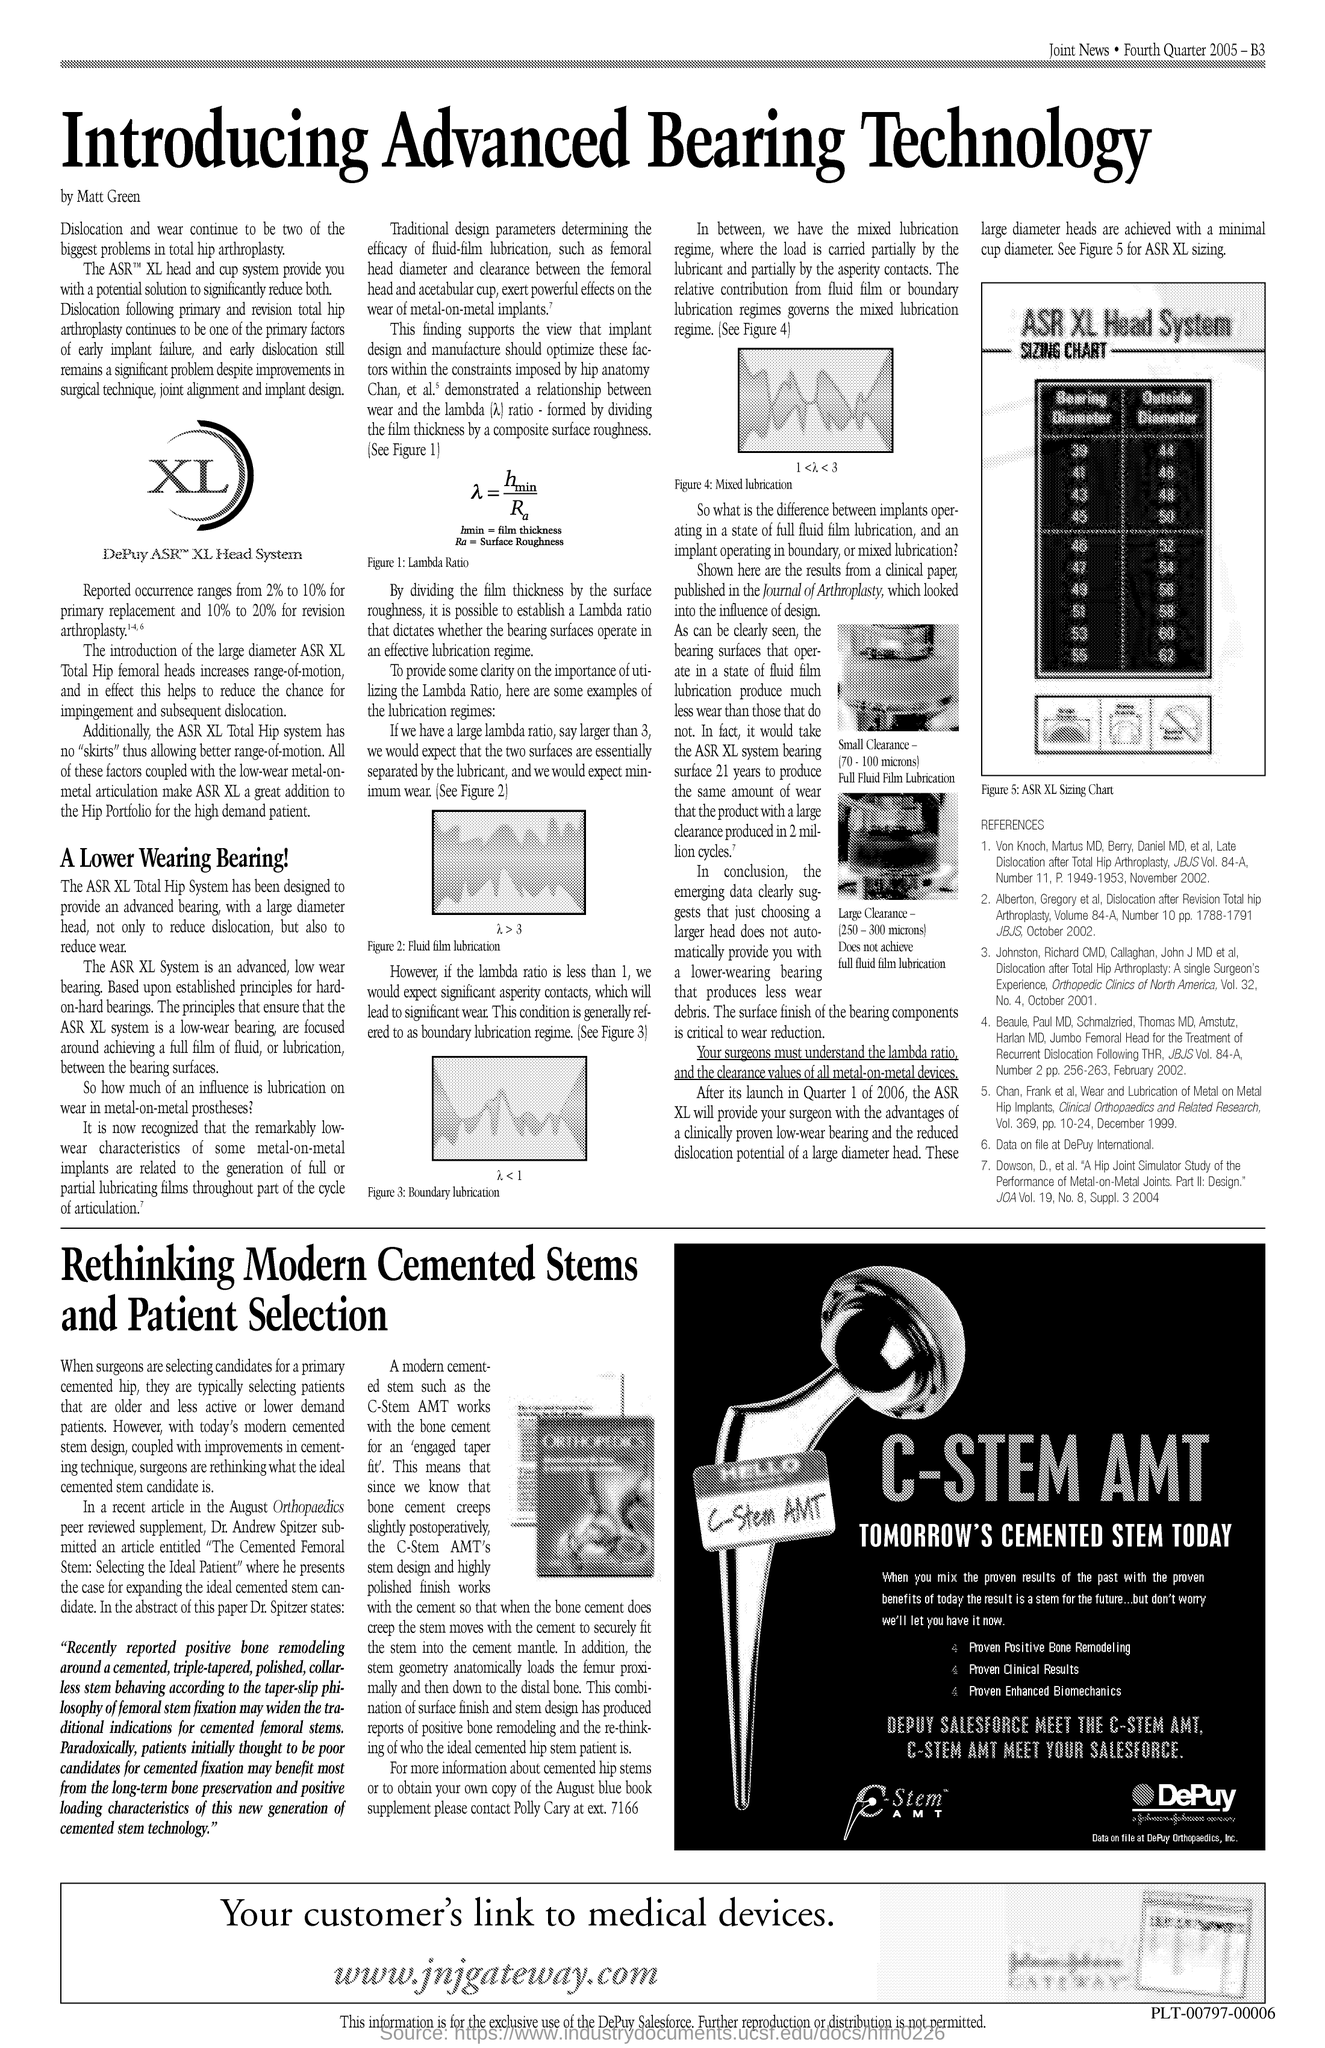Mention a couple of crucial points in this snapshot. The document is titled "Advanced Bearing Technology. 